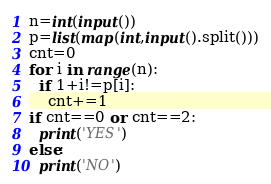<code> <loc_0><loc_0><loc_500><loc_500><_Python_>n=int(input())
p=list(map(int,input().split()))
cnt=0
for i in range(n):
  if 1+i!=p[i]:
    cnt+=1
if cnt==0 or cnt==2:
  print('YES')
else:
  print('NO')</code> 